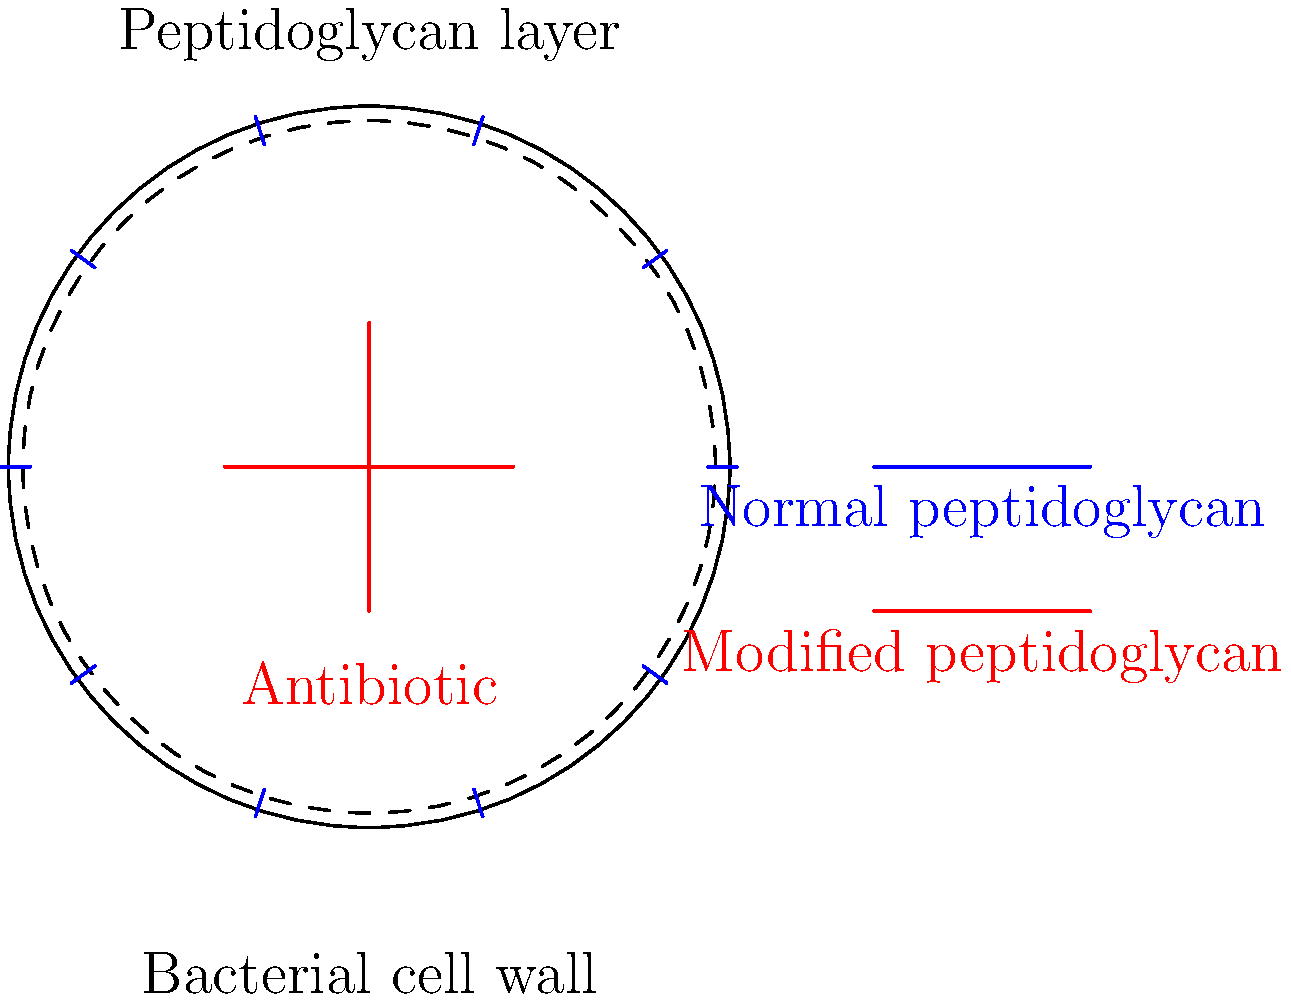In the schematic diagram of a bacterial cell wall, a red cross represents an antibiotic molecule attempting to bind to the peptidoglycan layer. However, some of the peptidoglycan strands are colored red instead of blue. What does this color change likely represent, and how does it contribute to antibiotic resistance? To understand the mechanism of antibiotic resistance depicted in this diagram, let's break it down step-by-step:

1. The blue lines in the outer layer represent normal peptidoglycan strands in the bacterial cell wall.

2. The red lines mixed with the blue ones represent modified peptidoglycan strands.

3. The red cross in the center represents an antibiotic molecule trying to bind to the peptidoglycan layer.

4. In normal circumstances, many antibiotics (like beta-lactams) work by binding to and disrupting the peptidoglycan layer, which is crucial for bacterial cell wall integrity.

5. The presence of red (modified) peptidoglycan strands suggests a structural change in the cell wall composition.

6. This structural modification likely alters the binding site or target of the antibiotic, making it more difficult or impossible for the antibiotic to attach effectively.

7. When antibiotics cannot bind to their target sites, they cannot disrupt the cell wall synthesis or integrity, rendering them ineffective.

8. This modification of the peptidoglycan layer is a common mechanism of antibiotic resistance, particularly against cell wall-targeting antibiotics.

9. Examples of such modifications include changes in the peptide cross-links (as in methicillin-resistant Staphylococcus aureus, MRSA) or alterations in the sugar components of the peptidoglycan.

10. These changes can be due to genetic mutations or acquisition of resistance genes that encode for modified cell wall components or enzymes that alter the existing structures.

Therefore, the red peptidoglycan strands likely represent a structural modification that prevents the antibiotic from binding effectively, thus conferring resistance to the bacteria against this particular antibiotic.
Answer: Modified peptidoglycan structure preventing antibiotic binding 